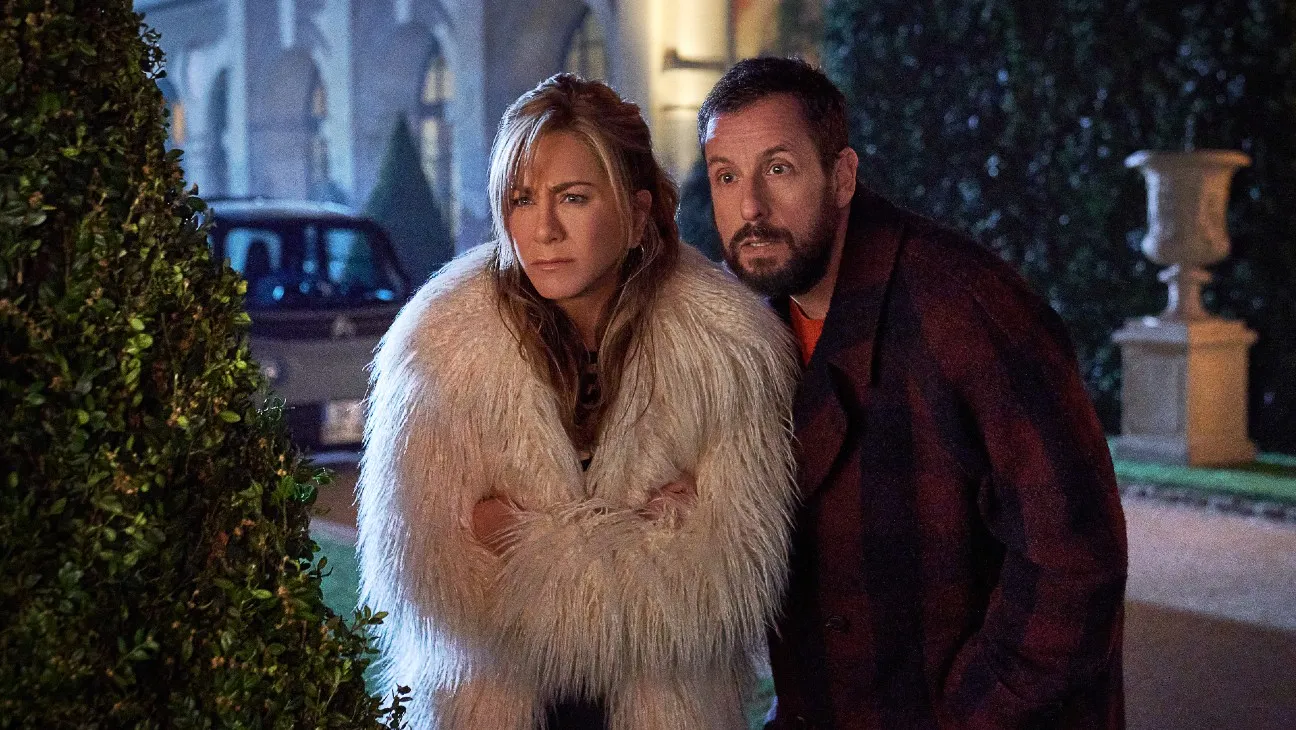Analyze the image in a comprehensive and detailed manner. The image depicts two individuals, likely actors, outdoors during a nighttime setting. The man wears a red coat and has a beard, while the woman is adorned in a voluminous white fur coat and maintains a neutral expression. They both are looking sideways with a curious or intent gaze, hinting at a potential action occurring off-camera. The background features a classical architecture and a sedan, underlining a serene yet possibly tense scenario. The image's overall mood is accentuated by the lighting and color tones, suggesting a cold, possibly winter season evening. 